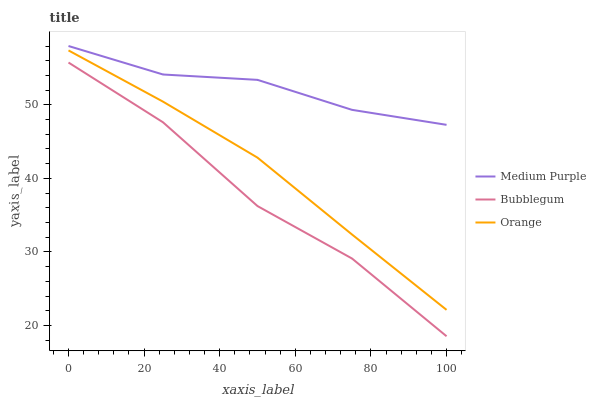Does Bubblegum have the minimum area under the curve?
Answer yes or no. Yes. Does Medium Purple have the maximum area under the curve?
Answer yes or no. Yes. Does Orange have the minimum area under the curve?
Answer yes or no. No. Does Orange have the maximum area under the curve?
Answer yes or no. No. Is Orange the smoothest?
Answer yes or no. Yes. Is Bubblegum the roughest?
Answer yes or no. Yes. Is Bubblegum the smoothest?
Answer yes or no. No. Is Orange the roughest?
Answer yes or no. No. Does Bubblegum have the lowest value?
Answer yes or no. Yes. Does Orange have the lowest value?
Answer yes or no. No. Does Medium Purple have the highest value?
Answer yes or no. Yes. Does Orange have the highest value?
Answer yes or no. No. Is Bubblegum less than Medium Purple?
Answer yes or no. Yes. Is Medium Purple greater than Bubblegum?
Answer yes or no. Yes. Does Bubblegum intersect Medium Purple?
Answer yes or no. No. 